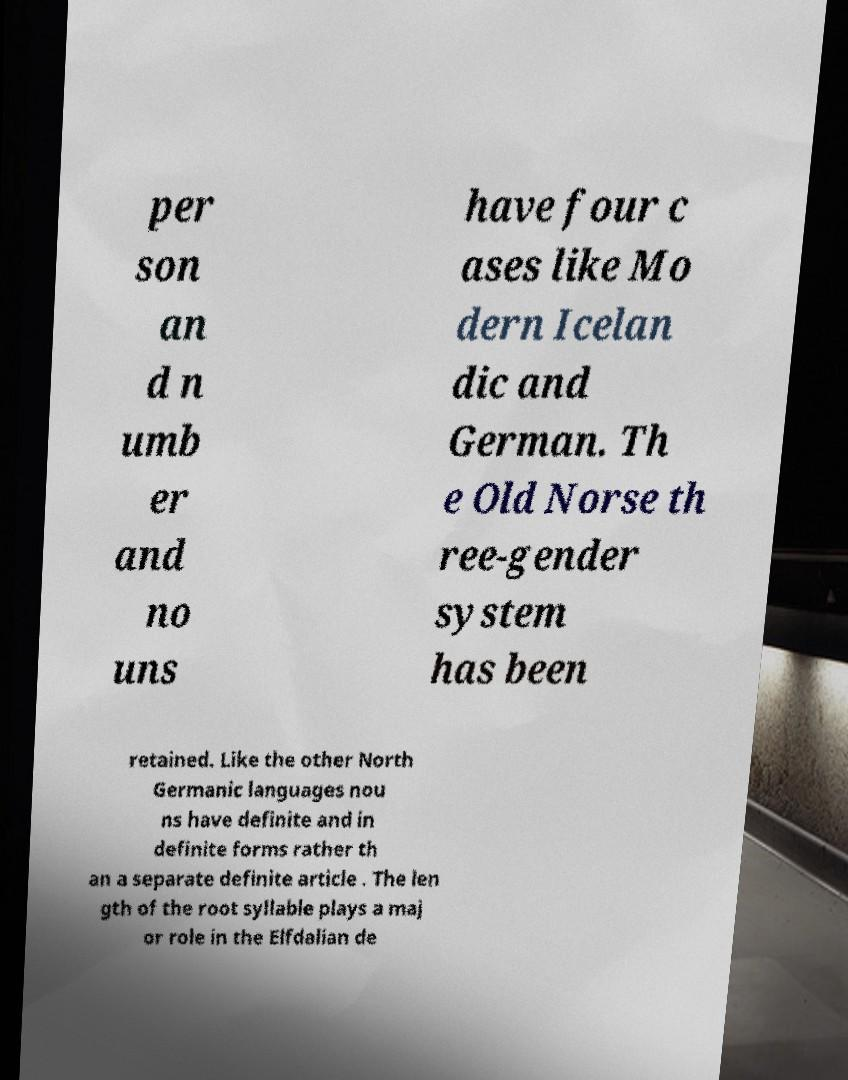Please read and relay the text visible in this image. What does it say? per son an d n umb er and no uns have four c ases like Mo dern Icelan dic and German. Th e Old Norse th ree-gender system has been retained. Like the other North Germanic languages nou ns have definite and in definite forms rather th an a separate definite article . The len gth of the root syllable plays a maj or role in the Elfdalian de 